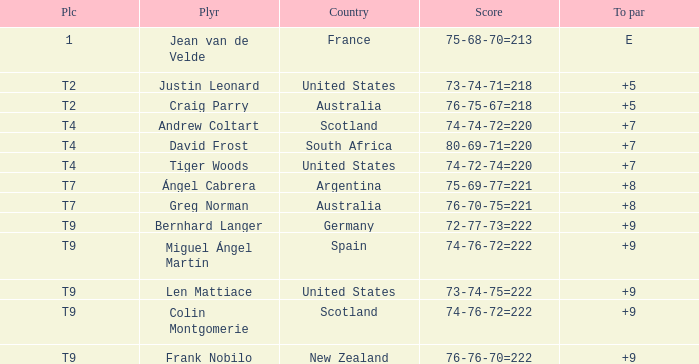Which player from Scotland has a To Par score of +7? Andrew Coltart. 